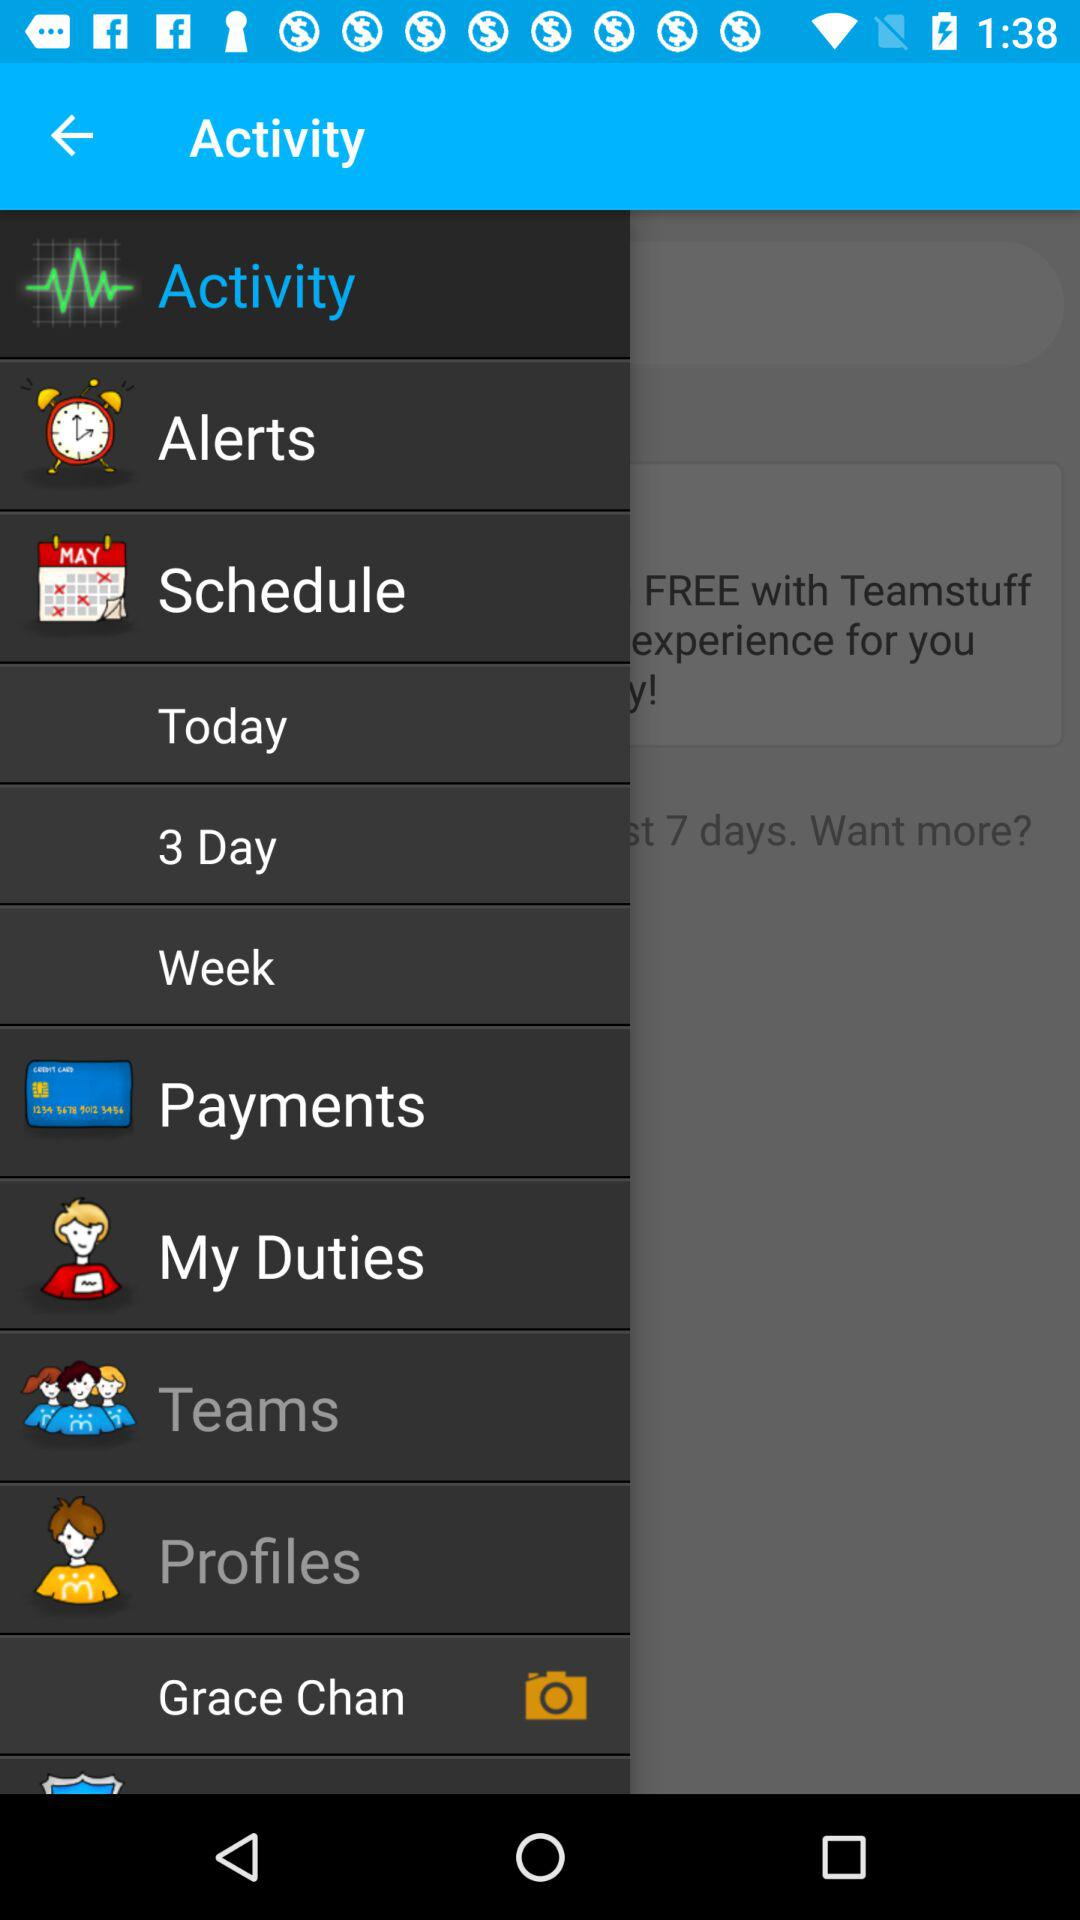How many days are shown?
When the provided information is insufficient, respond with <no answer>. <no answer> 